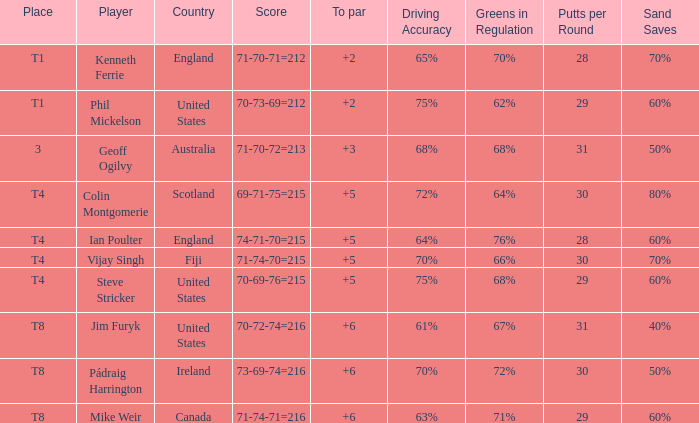What score to highest to par did Mike Weir achieve? 6.0. 